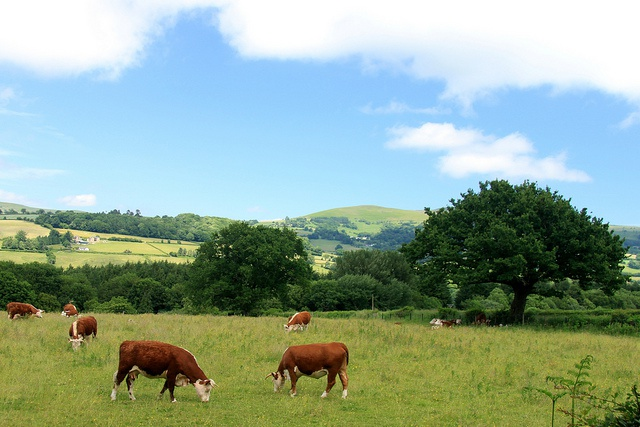Describe the objects in this image and their specific colors. I can see cow in white, black, maroon, and olive tones, cow in white, maroon, black, brown, and olive tones, cow in white, maroon, tan, black, and brown tones, cow in white, maroon, black, and brown tones, and cow in white, brown, tan, maroon, and olive tones in this image. 